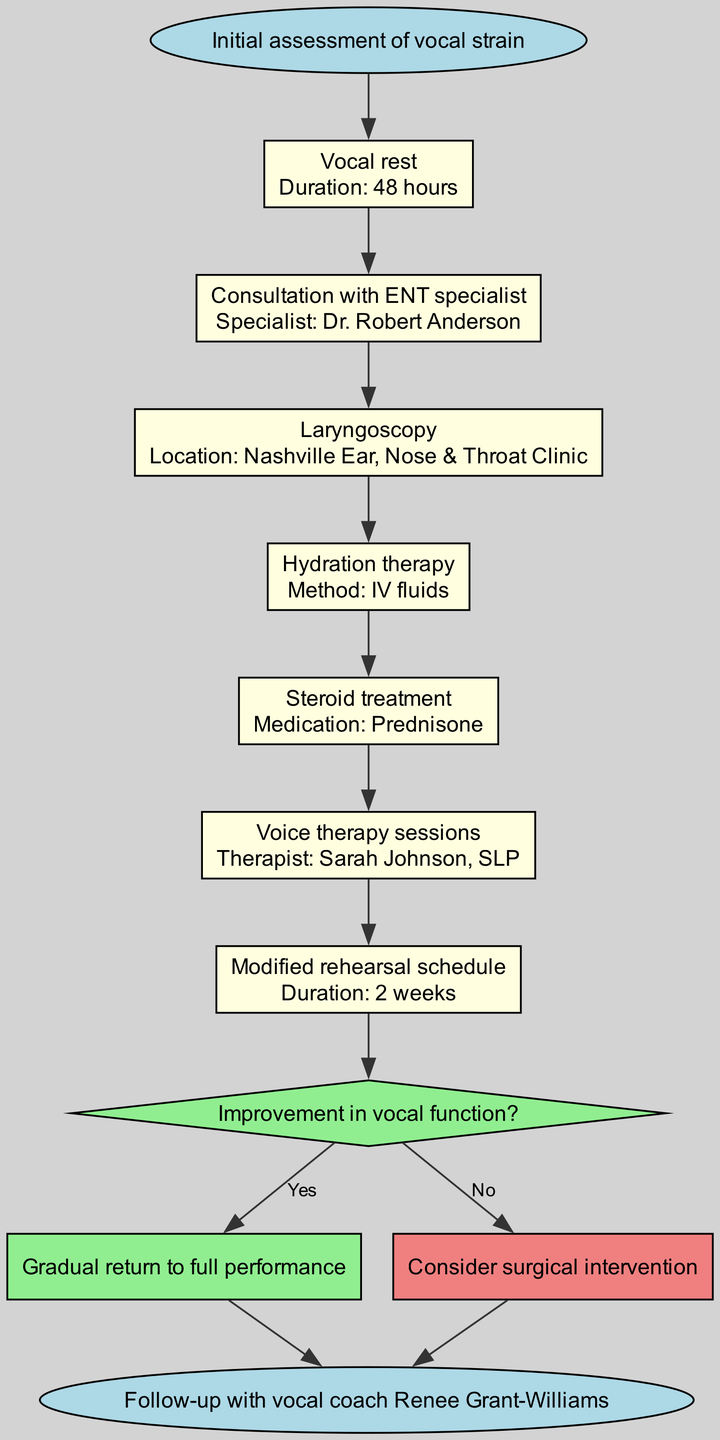What is the first step in the clinical pathway? The first step is "Initial assessment of vocal strain," which is the starting point of the entire pathway.
Answer: Initial assessment of vocal strain How many steps are in the clinical pathway? By counting the steps listed (excluding the start and end nodes), there are a total of 7 steps.
Answer: 7 What is the duration of vocal rest? The duration for vocal rest is specified as "48 hours" in the diagram.
Answer: 48 hours Who is the therapist for voice therapy sessions? The therapist for voice therapy sessions is identified as "Sarah Johnson, SLP."
Answer: Sarah Johnson, SLP What happens if there is improvement in vocal function? If there is improvement in vocal function, the pathway indicates a "Gradual return to full performance."
Answer: Gradual return to full performance What is the decision point in the clinical pathway? The decision point is based on the condition "Improvement in vocal function?" which guides the following steps.
Answer: Improvement in vocal function? What medication is used in steroid treatment? The medication specified for steroid treatment is "Prednisone."
Answer: Prednisone What is the duration of the modified rehearsal schedule? The duration for the modified rehearsal schedule is indicated as "2 weeks."
Answer: 2 weeks Where is the laryngoscopy conducted? The laryngoscopy is conducted at the "Nashville Ear, Nose & Throat Clinic."
Answer: Nashville Ear, Nose & Throat Clinic 